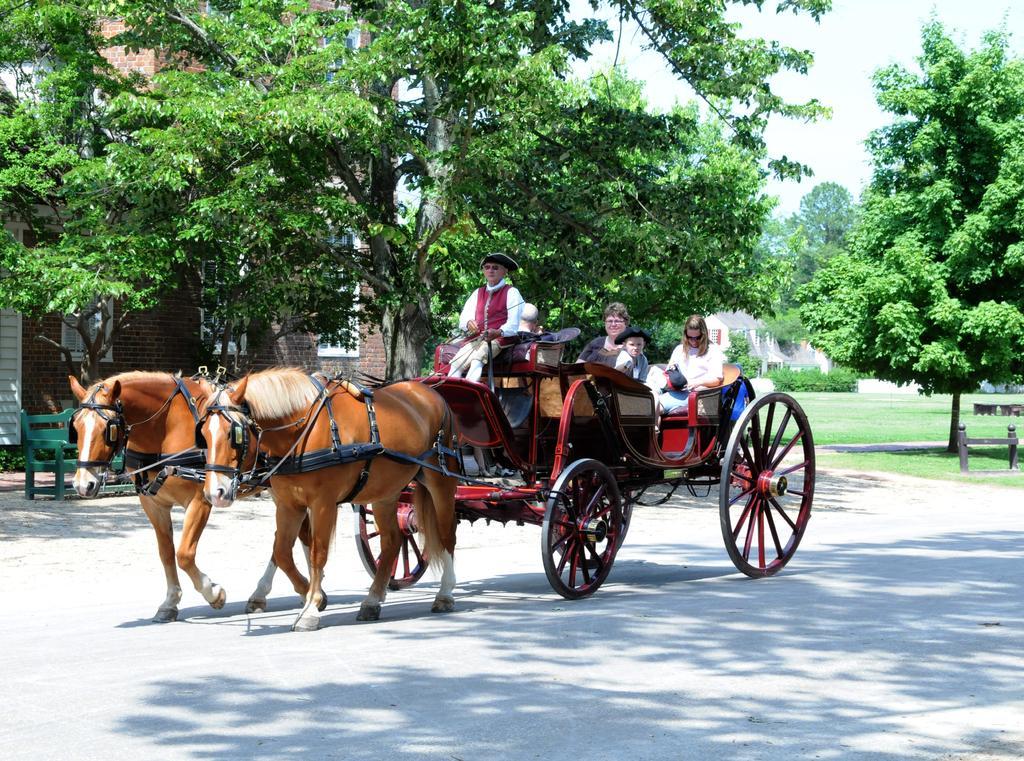Describe this image in one or two sentences. In the foreground of this image, there are people sitting on a horse cart which is moving on the road. In the background, there are trees, grassland, few houses, sky and the green color bench. 